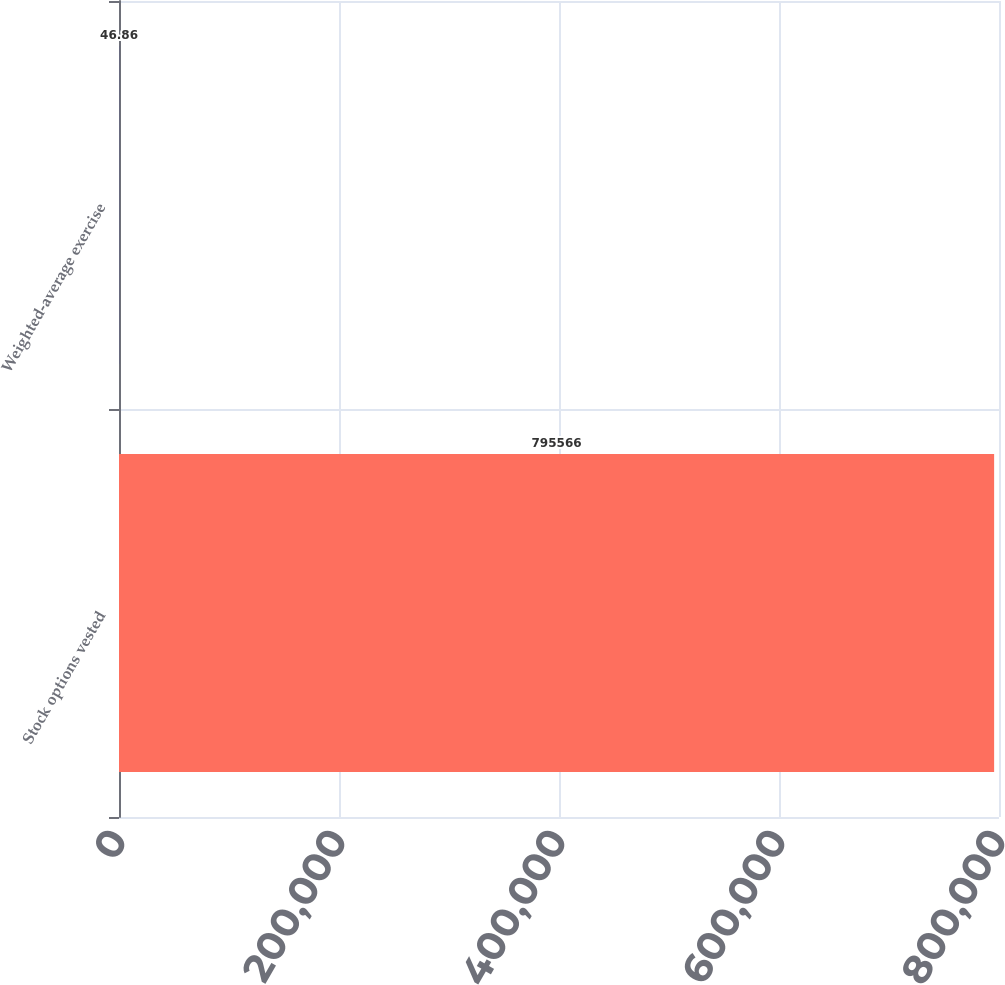Convert chart. <chart><loc_0><loc_0><loc_500><loc_500><bar_chart><fcel>Stock options vested<fcel>Weighted-average exercise<nl><fcel>795566<fcel>46.86<nl></chart> 